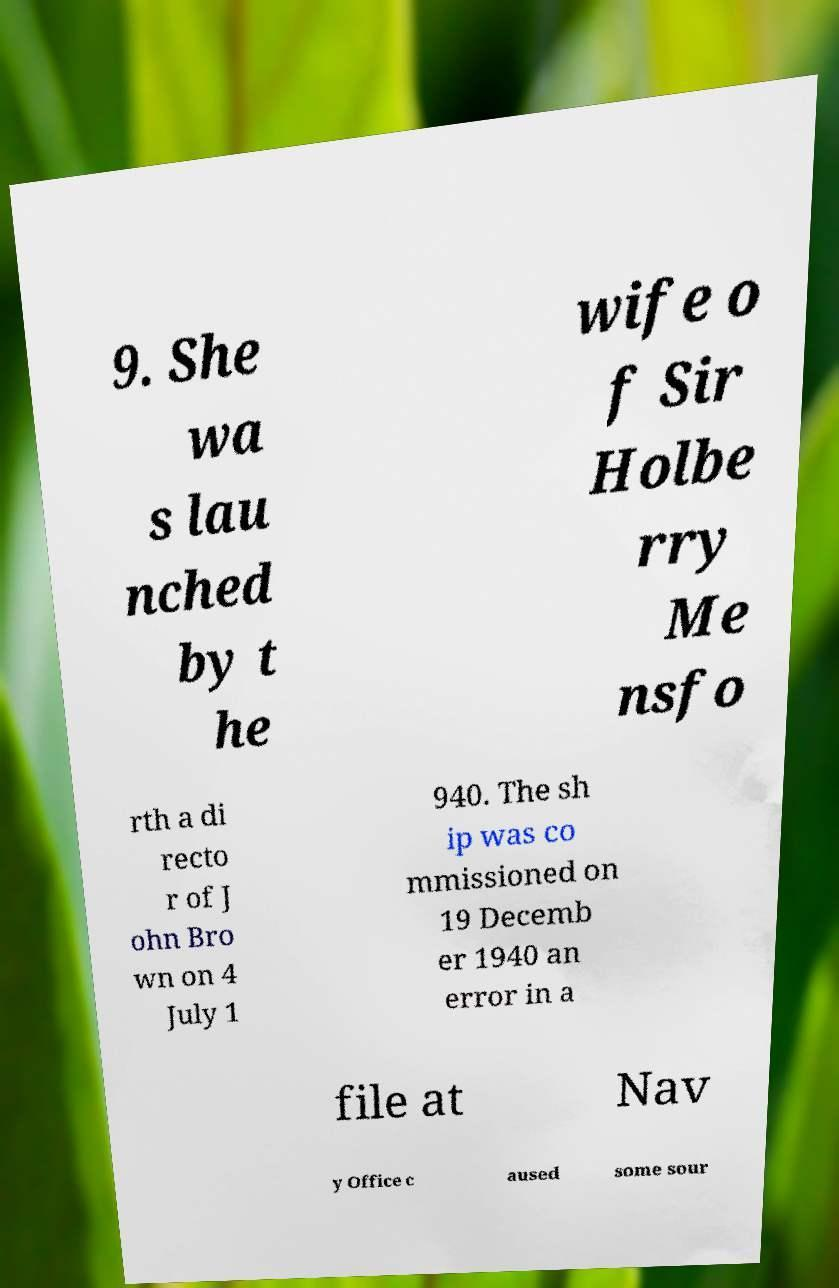There's text embedded in this image that I need extracted. Can you transcribe it verbatim? 9. She wa s lau nched by t he wife o f Sir Holbe rry Me nsfo rth a di recto r of J ohn Bro wn on 4 July 1 940. The sh ip was co mmissioned on 19 Decemb er 1940 an error in a file at Nav y Office c aused some sour 